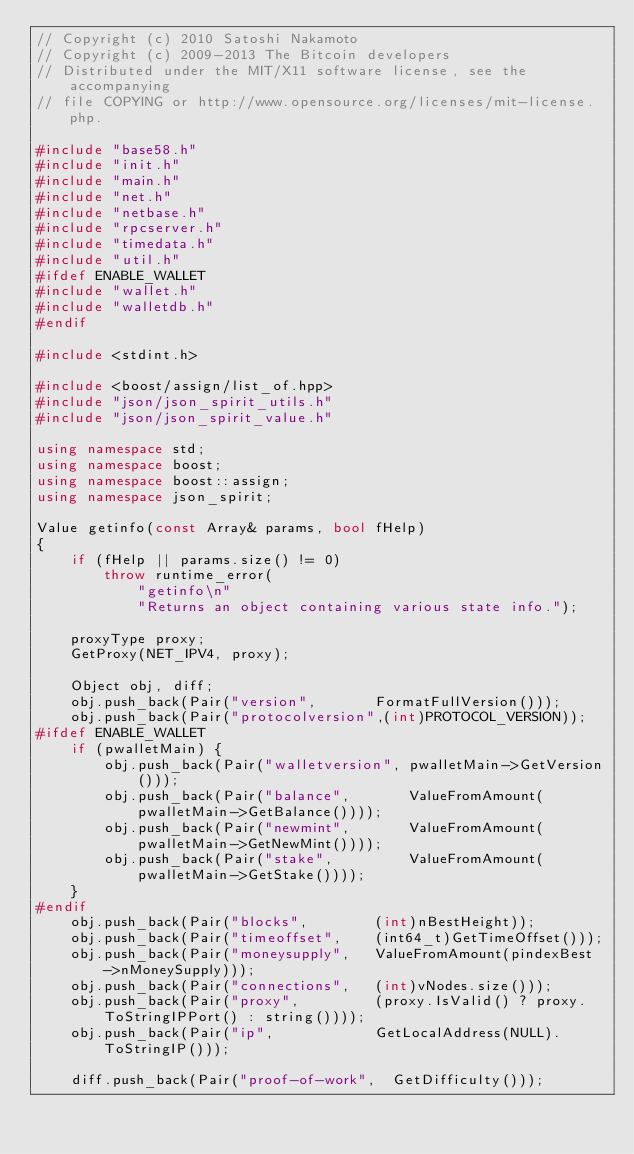Convert code to text. <code><loc_0><loc_0><loc_500><loc_500><_C++_>// Copyright (c) 2010 Satoshi Nakamoto
// Copyright (c) 2009-2013 The Bitcoin developers
// Distributed under the MIT/X11 software license, see the accompanying
// file COPYING or http://www.opensource.org/licenses/mit-license.php.

#include "base58.h"
#include "init.h"
#include "main.h"
#include "net.h"
#include "netbase.h"
#include "rpcserver.h"
#include "timedata.h"
#include "util.h"
#ifdef ENABLE_WALLET
#include "wallet.h"
#include "walletdb.h"
#endif

#include <stdint.h>

#include <boost/assign/list_of.hpp>
#include "json/json_spirit_utils.h"
#include "json/json_spirit_value.h"

using namespace std;
using namespace boost;
using namespace boost::assign;
using namespace json_spirit;

Value getinfo(const Array& params, bool fHelp)
{
    if (fHelp || params.size() != 0)
        throw runtime_error(
            "getinfo\n"
            "Returns an object containing various state info.");

    proxyType proxy;
    GetProxy(NET_IPV4, proxy);

    Object obj, diff;
    obj.push_back(Pair("version",       FormatFullVersion()));
    obj.push_back(Pair("protocolversion",(int)PROTOCOL_VERSION));
#ifdef ENABLE_WALLET
    if (pwalletMain) {
        obj.push_back(Pair("walletversion", pwalletMain->GetVersion()));
        obj.push_back(Pair("balance",       ValueFromAmount(pwalletMain->GetBalance())));
        obj.push_back(Pair("newmint",       ValueFromAmount(pwalletMain->GetNewMint())));
        obj.push_back(Pair("stake",         ValueFromAmount(pwalletMain->GetStake())));
    }
#endif
    obj.push_back(Pair("blocks",        (int)nBestHeight));
    obj.push_back(Pair("timeoffset",    (int64_t)GetTimeOffset()));
    obj.push_back(Pair("moneysupply",   ValueFromAmount(pindexBest->nMoneySupply)));
    obj.push_back(Pair("connections",   (int)vNodes.size()));
    obj.push_back(Pair("proxy",         (proxy.IsValid() ? proxy.ToStringIPPort() : string())));
    obj.push_back(Pair("ip",            GetLocalAddress(NULL).ToStringIP()));

    diff.push_back(Pair("proof-of-work",  GetDifficulty()));</code> 